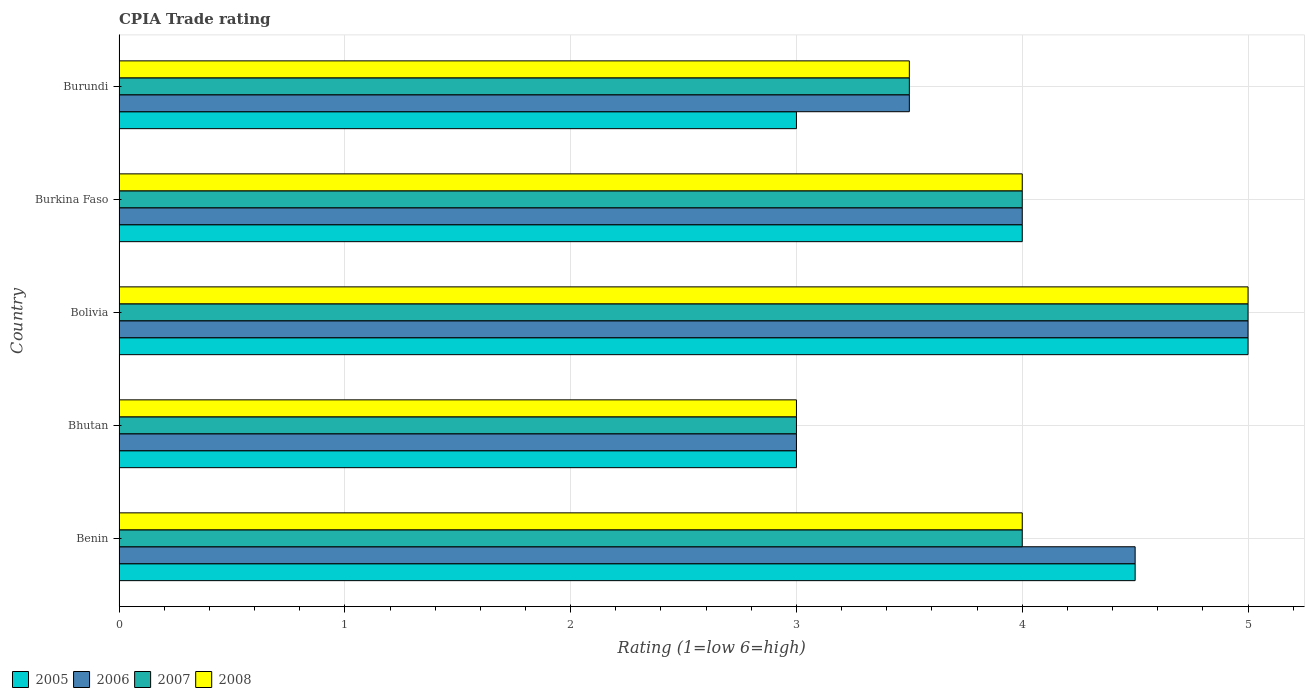Are the number of bars on each tick of the Y-axis equal?
Keep it short and to the point. Yes. How many bars are there on the 1st tick from the bottom?
Keep it short and to the point. 4. What is the label of the 3rd group of bars from the top?
Your answer should be compact. Bolivia. In how many cases, is the number of bars for a given country not equal to the number of legend labels?
Provide a short and direct response. 0. In which country was the CPIA rating in 2008 minimum?
Ensure brevity in your answer.  Bhutan. What is the difference between the CPIA rating in 2007 in Bhutan and that in Bolivia?
Provide a succinct answer. -2. What is the average CPIA rating in 2005 per country?
Offer a very short reply. 3.9. What is the difference between the CPIA rating in 2008 and CPIA rating in 2007 in Bolivia?
Your answer should be very brief. 0. What is the ratio of the CPIA rating in 2008 in Benin to that in Burkina Faso?
Keep it short and to the point. 1. Is the CPIA rating in 2005 in Bhutan less than that in Burkina Faso?
Provide a succinct answer. Yes. Is the difference between the CPIA rating in 2008 in Bolivia and Burundi greater than the difference between the CPIA rating in 2007 in Bolivia and Burundi?
Offer a very short reply. No. What is the difference between the highest and the second highest CPIA rating in 2008?
Keep it short and to the point. 1. What is the difference between the highest and the lowest CPIA rating in 2006?
Offer a terse response. 2. In how many countries, is the CPIA rating in 2008 greater than the average CPIA rating in 2008 taken over all countries?
Keep it short and to the point. 3. Is the sum of the CPIA rating in 2005 in Bolivia and Burundi greater than the maximum CPIA rating in 2008 across all countries?
Your answer should be compact. Yes. What does the 3rd bar from the top in Benin represents?
Provide a short and direct response. 2006. Is it the case that in every country, the sum of the CPIA rating in 2006 and CPIA rating in 2008 is greater than the CPIA rating in 2007?
Offer a terse response. Yes. How many bars are there?
Make the answer very short. 20. How many countries are there in the graph?
Provide a short and direct response. 5. Does the graph contain any zero values?
Give a very brief answer. No. Where does the legend appear in the graph?
Your answer should be compact. Bottom left. How many legend labels are there?
Keep it short and to the point. 4. What is the title of the graph?
Keep it short and to the point. CPIA Trade rating. Does "1976" appear as one of the legend labels in the graph?
Give a very brief answer. No. What is the Rating (1=low 6=high) of 2008 in Benin?
Your answer should be compact. 4. What is the Rating (1=low 6=high) of 2006 in Bhutan?
Your answer should be very brief. 3. What is the Rating (1=low 6=high) of 2008 in Bhutan?
Make the answer very short. 3. What is the Rating (1=low 6=high) of 2008 in Bolivia?
Make the answer very short. 5. What is the Rating (1=low 6=high) of 2005 in Burundi?
Make the answer very short. 3. What is the Rating (1=low 6=high) in 2007 in Burundi?
Your answer should be compact. 3.5. What is the Rating (1=low 6=high) in 2008 in Burundi?
Offer a very short reply. 3.5. Across all countries, what is the maximum Rating (1=low 6=high) in 2006?
Offer a very short reply. 5. Across all countries, what is the minimum Rating (1=low 6=high) of 2005?
Ensure brevity in your answer.  3. Across all countries, what is the minimum Rating (1=low 6=high) in 2006?
Your response must be concise. 3. What is the total Rating (1=low 6=high) in 2006 in the graph?
Provide a succinct answer. 20. What is the total Rating (1=low 6=high) in 2007 in the graph?
Keep it short and to the point. 19.5. What is the difference between the Rating (1=low 6=high) in 2006 in Benin and that in Bhutan?
Your answer should be compact. 1.5. What is the difference between the Rating (1=low 6=high) of 2005 in Benin and that in Bolivia?
Your answer should be very brief. -0.5. What is the difference between the Rating (1=low 6=high) in 2005 in Benin and that in Burkina Faso?
Provide a short and direct response. 0.5. What is the difference between the Rating (1=low 6=high) of 2007 in Benin and that in Burkina Faso?
Give a very brief answer. 0. What is the difference between the Rating (1=low 6=high) in 2005 in Benin and that in Burundi?
Make the answer very short. 1.5. What is the difference between the Rating (1=low 6=high) of 2008 in Benin and that in Burundi?
Provide a short and direct response. 0.5. What is the difference between the Rating (1=low 6=high) of 2008 in Bhutan and that in Bolivia?
Give a very brief answer. -2. What is the difference between the Rating (1=low 6=high) of 2005 in Bhutan and that in Burkina Faso?
Your response must be concise. -1. What is the difference between the Rating (1=low 6=high) in 2006 in Bhutan and that in Burkina Faso?
Your response must be concise. -1. What is the difference between the Rating (1=low 6=high) in 2008 in Bhutan and that in Burkina Faso?
Give a very brief answer. -1. What is the difference between the Rating (1=low 6=high) of 2007 in Bhutan and that in Burundi?
Provide a succinct answer. -0.5. What is the difference between the Rating (1=low 6=high) of 2008 in Bhutan and that in Burundi?
Offer a very short reply. -0.5. What is the difference between the Rating (1=low 6=high) in 2005 in Bolivia and that in Burkina Faso?
Give a very brief answer. 1. What is the difference between the Rating (1=low 6=high) of 2007 in Bolivia and that in Burkina Faso?
Provide a short and direct response. 1. What is the difference between the Rating (1=low 6=high) in 2005 in Bolivia and that in Burundi?
Ensure brevity in your answer.  2. What is the difference between the Rating (1=low 6=high) in 2006 in Bolivia and that in Burundi?
Provide a succinct answer. 1.5. What is the difference between the Rating (1=low 6=high) in 2007 in Bolivia and that in Burundi?
Your response must be concise. 1.5. What is the difference between the Rating (1=low 6=high) of 2005 in Burkina Faso and that in Burundi?
Give a very brief answer. 1. What is the difference between the Rating (1=low 6=high) of 2006 in Burkina Faso and that in Burundi?
Your answer should be very brief. 0.5. What is the difference between the Rating (1=low 6=high) of 2008 in Burkina Faso and that in Burundi?
Make the answer very short. 0.5. What is the difference between the Rating (1=low 6=high) of 2005 in Benin and the Rating (1=low 6=high) of 2007 in Bhutan?
Your answer should be very brief. 1.5. What is the difference between the Rating (1=low 6=high) of 2005 in Benin and the Rating (1=low 6=high) of 2008 in Bhutan?
Your answer should be compact. 1.5. What is the difference between the Rating (1=low 6=high) in 2007 in Benin and the Rating (1=low 6=high) in 2008 in Bhutan?
Your answer should be very brief. 1. What is the difference between the Rating (1=low 6=high) of 2005 in Benin and the Rating (1=low 6=high) of 2006 in Bolivia?
Ensure brevity in your answer.  -0.5. What is the difference between the Rating (1=low 6=high) in 2005 in Benin and the Rating (1=low 6=high) in 2007 in Bolivia?
Keep it short and to the point. -0.5. What is the difference between the Rating (1=low 6=high) of 2006 in Benin and the Rating (1=low 6=high) of 2007 in Bolivia?
Give a very brief answer. -0.5. What is the difference between the Rating (1=low 6=high) of 2005 in Benin and the Rating (1=low 6=high) of 2007 in Burkina Faso?
Make the answer very short. 0.5. What is the difference between the Rating (1=low 6=high) in 2006 in Benin and the Rating (1=low 6=high) in 2007 in Burkina Faso?
Your response must be concise. 0.5. What is the difference between the Rating (1=low 6=high) in 2005 in Benin and the Rating (1=low 6=high) in 2008 in Burundi?
Your response must be concise. 1. What is the difference between the Rating (1=low 6=high) of 2006 in Benin and the Rating (1=low 6=high) of 2007 in Burundi?
Offer a terse response. 1. What is the difference between the Rating (1=low 6=high) in 2005 in Bhutan and the Rating (1=low 6=high) in 2007 in Bolivia?
Your answer should be very brief. -2. What is the difference between the Rating (1=low 6=high) of 2005 in Bhutan and the Rating (1=low 6=high) of 2008 in Bolivia?
Provide a short and direct response. -2. What is the difference between the Rating (1=low 6=high) of 2007 in Bhutan and the Rating (1=low 6=high) of 2008 in Bolivia?
Give a very brief answer. -2. What is the difference between the Rating (1=low 6=high) of 2006 in Bhutan and the Rating (1=low 6=high) of 2007 in Burkina Faso?
Your answer should be very brief. -1. What is the difference between the Rating (1=low 6=high) in 2006 in Bhutan and the Rating (1=low 6=high) in 2008 in Burkina Faso?
Make the answer very short. -1. What is the difference between the Rating (1=low 6=high) in 2005 in Bhutan and the Rating (1=low 6=high) in 2006 in Burundi?
Your response must be concise. -0.5. What is the difference between the Rating (1=low 6=high) in 2005 in Bhutan and the Rating (1=low 6=high) in 2007 in Burundi?
Ensure brevity in your answer.  -0.5. What is the difference between the Rating (1=low 6=high) in 2005 in Bhutan and the Rating (1=low 6=high) in 2008 in Burundi?
Provide a succinct answer. -0.5. What is the difference between the Rating (1=low 6=high) in 2006 in Bhutan and the Rating (1=low 6=high) in 2008 in Burundi?
Keep it short and to the point. -0.5. What is the difference between the Rating (1=low 6=high) of 2005 in Bolivia and the Rating (1=low 6=high) of 2006 in Burkina Faso?
Offer a very short reply. 1. What is the difference between the Rating (1=low 6=high) of 2006 in Bolivia and the Rating (1=low 6=high) of 2007 in Burkina Faso?
Your answer should be very brief. 1. What is the difference between the Rating (1=low 6=high) of 2006 in Bolivia and the Rating (1=low 6=high) of 2008 in Burkina Faso?
Keep it short and to the point. 1. What is the difference between the Rating (1=low 6=high) in 2005 in Bolivia and the Rating (1=low 6=high) in 2006 in Burundi?
Provide a succinct answer. 1.5. What is the difference between the Rating (1=low 6=high) in 2005 in Bolivia and the Rating (1=low 6=high) in 2007 in Burundi?
Offer a very short reply. 1.5. What is the difference between the Rating (1=low 6=high) in 2006 in Bolivia and the Rating (1=low 6=high) in 2007 in Burundi?
Keep it short and to the point. 1.5. What is the difference between the Rating (1=low 6=high) of 2006 in Bolivia and the Rating (1=low 6=high) of 2008 in Burundi?
Make the answer very short. 1.5. What is the difference between the Rating (1=low 6=high) in 2006 in Burkina Faso and the Rating (1=low 6=high) in 2007 in Burundi?
Your response must be concise. 0.5. What is the difference between the Rating (1=low 6=high) in 2006 in Burkina Faso and the Rating (1=low 6=high) in 2008 in Burundi?
Make the answer very short. 0.5. What is the average Rating (1=low 6=high) in 2005 per country?
Your response must be concise. 3.9. What is the average Rating (1=low 6=high) in 2006 per country?
Keep it short and to the point. 4. What is the average Rating (1=low 6=high) of 2007 per country?
Offer a terse response. 3.9. What is the difference between the Rating (1=low 6=high) in 2006 and Rating (1=low 6=high) in 2007 in Benin?
Provide a succinct answer. 0.5. What is the difference between the Rating (1=low 6=high) of 2005 and Rating (1=low 6=high) of 2007 in Bhutan?
Your answer should be compact. 0. What is the difference between the Rating (1=low 6=high) of 2005 and Rating (1=low 6=high) of 2008 in Bhutan?
Offer a terse response. 0. What is the difference between the Rating (1=low 6=high) of 2005 and Rating (1=low 6=high) of 2006 in Bolivia?
Make the answer very short. 0. What is the difference between the Rating (1=low 6=high) of 2005 and Rating (1=low 6=high) of 2007 in Bolivia?
Offer a terse response. 0. What is the difference between the Rating (1=low 6=high) of 2005 and Rating (1=low 6=high) of 2008 in Bolivia?
Your answer should be very brief. 0. What is the difference between the Rating (1=low 6=high) in 2006 and Rating (1=low 6=high) in 2008 in Bolivia?
Provide a short and direct response. 0. What is the difference between the Rating (1=low 6=high) in 2007 and Rating (1=low 6=high) in 2008 in Bolivia?
Provide a short and direct response. 0. What is the difference between the Rating (1=low 6=high) of 2006 and Rating (1=low 6=high) of 2008 in Burkina Faso?
Your answer should be compact. 0. What is the difference between the Rating (1=low 6=high) in 2005 and Rating (1=low 6=high) in 2007 in Burundi?
Offer a terse response. -0.5. What is the difference between the Rating (1=low 6=high) in 2005 and Rating (1=low 6=high) in 2008 in Burundi?
Make the answer very short. -0.5. What is the difference between the Rating (1=low 6=high) of 2006 and Rating (1=low 6=high) of 2007 in Burundi?
Give a very brief answer. 0. What is the ratio of the Rating (1=low 6=high) in 2006 in Benin to that in Bhutan?
Offer a terse response. 1.5. What is the ratio of the Rating (1=low 6=high) in 2007 in Benin to that in Bhutan?
Make the answer very short. 1.33. What is the ratio of the Rating (1=low 6=high) of 2005 in Benin to that in Bolivia?
Your answer should be compact. 0.9. What is the ratio of the Rating (1=low 6=high) of 2006 in Benin to that in Bolivia?
Your answer should be compact. 0.9. What is the ratio of the Rating (1=low 6=high) of 2005 in Benin to that in Burkina Faso?
Ensure brevity in your answer.  1.12. What is the ratio of the Rating (1=low 6=high) of 2006 in Benin to that in Burkina Faso?
Keep it short and to the point. 1.12. What is the ratio of the Rating (1=low 6=high) in 2005 in Benin to that in Burundi?
Provide a short and direct response. 1.5. What is the ratio of the Rating (1=low 6=high) in 2006 in Benin to that in Burundi?
Provide a short and direct response. 1.29. What is the ratio of the Rating (1=low 6=high) of 2008 in Benin to that in Burundi?
Keep it short and to the point. 1.14. What is the ratio of the Rating (1=low 6=high) of 2006 in Bhutan to that in Bolivia?
Your response must be concise. 0.6. What is the ratio of the Rating (1=low 6=high) in 2008 in Bhutan to that in Bolivia?
Offer a very short reply. 0.6. What is the ratio of the Rating (1=low 6=high) in 2005 in Bhutan to that in Burkina Faso?
Provide a succinct answer. 0.75. What is the ratio of the Rating (1=low 6=high) in 2007 in Bhutan to that in Burkina Faso?
Give a very brief answer. 0.75. What is the ratio of the Rating (1=low 6=high) of 2005 in Bhutan to that in Burundi?
Keep it short and to the point. 1. What is the ratio of the Rating (1=low 6=high) of 2006 in Bhutan to that in Burundi?
Give a very brief answer. 0.86. What is the ratio of the Rating (1=low 6=high) of 2005 in Bolivia to that in Burkina Faso?
Your response must be concise. 1.25. What is the ratio of the Rating (1=low 6=high) of 2006 in Bolivia to that in Burkina Faso?
Your response must be concise. 1.25. What is the ratio of the Rating (1=low 6=high) in 2007 in Bolivia to that in Burkina Faso?
Your answer should be very brief. 1.25. What is the ratio of the Rating (1=low 6=high) in 2008 in Bolivia to that in Burkina Faso?
Your answer should be very brief. 1.25. What is the ratio of the Rating (1=low 6=high) in 2006 in Bolivia to that in Burundi?
Make the answer very short. 1.43. What is the ratio of the Rating (1=low 6=high) in 2007 in Bolivia to that in Burundi?
Your answer should be compact. 1.43. What is the ratio of the Rating (1=low 6=high) in 2008 in Bolivia to that in Burundi?
Make the answer very short. 1.43. What is the ratio of the Rating (1=low 6=high) of 2006 in Burkina Faso to that in Burundi?
Make the answer very short. 1.14. What is the ratio of the Rating (1=low 6=high) of 2007 in Burkina Faso to that in Burundi?
Offer a very short reply. 1.14. What is the ratio of the Rating (1=low 6=high) of 2008 in Burkina Faso to that in Burundi?
Provide a succinct answer. 1.14. What is the difference between the highest and the second highest Rating (1=low 6=high) in 2007?
Keep it short and to the point. 1. What is the difference between the highest and the second highest Rating (1=low 6=high) in 2008?
Your answer should be compact. 1. What is the difference between the highest and the lowest Rating (1=low 6=high) of 2006?
Your answer should be very brief. 2. What is the difference between the highest and the lowest Rating (1=low 6=high) in 2007?
Your answer should be very brief. 2. 